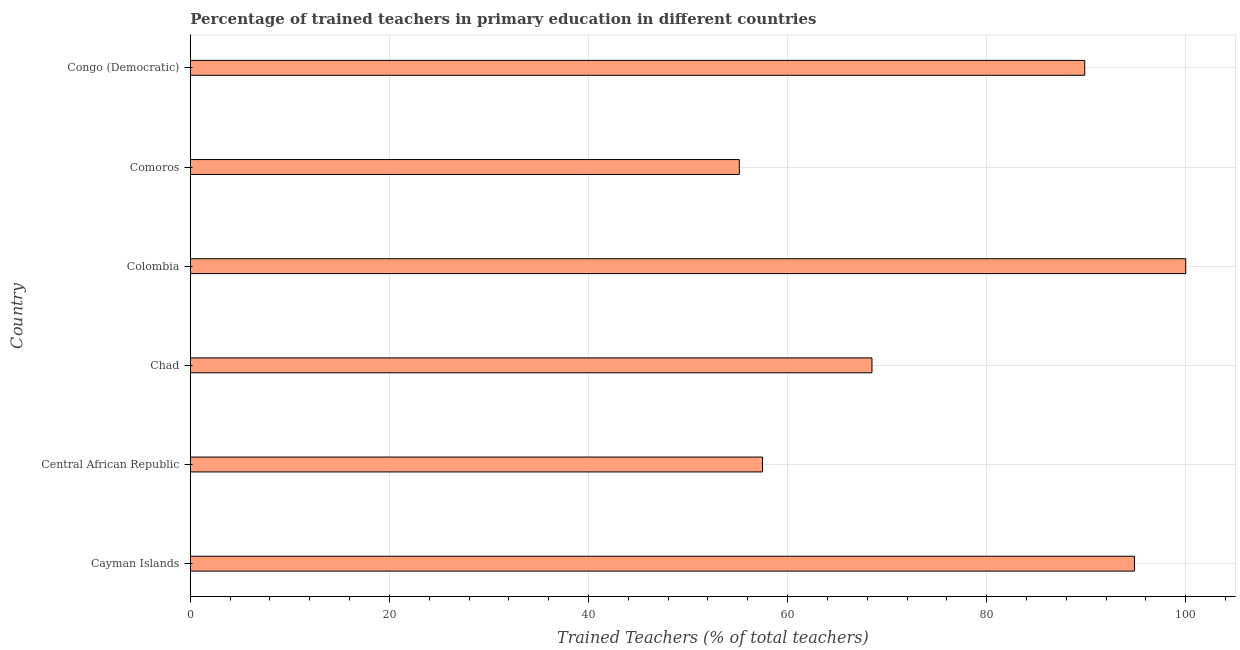Does the graph contain grids?
Give a very brief answer. Yes. What is the title of the graph?
Provide a short and direct response. Percentage of trained teachers in primary education in different countries. What is the label or title of the X-axis?
Your response must be concise. Trained Teachers (% of total teachers). What is the label or title of the Y-axis?
Ensure brevity in your answer.  Country. What is the percentage of trained teachers in Chad?
Make the answer very short. 68.48. Across all countries, what is the minimum percentage of trained teachers?
Your answer should be compact. 55.15. In which country was the percentage of trained teachers maximum?
Provide a succinct answer. Colombia. In which country was the percentage of trained teachers minimum?
Give a very brief answer. Comoros. What is the sum of the percentage of trained teachers?
Your response must be concise. 465.82. What is the difference between the percentage of trained teachers in Colombia and Congo (Democratic)?
Keep it short and to the point. 10.15. What is the average percentage of trained teachers per country?
Give a very brief answer. 77.64. What is the median percentage of trained teachers?
Make the answer very short. 79.17. In how many countries, is the percentage of trained teachers greater than 52 %?
Your response must be concise. 6. What is the ratio of the percentage of trained teachers in Comoros to that in Congo (Democratic)?
Give a very brief answer. 0.61. What is the difference between the highest and the second highest percentage of trained teachers?
Offer a very short reply. 5.15. What is the difference between the highest and the lowest percentage of trained teachers?
Your answer should be compact. 44.85. In how many countries, is the percentage of trained teachers greater than the average percentage of trained teachers taken over all countries?
Provide a succinct answer. 3. Are all the bars in the graph horizontal?
Provide a succinct answer. Yes. How many countries are there in the graph?
Ensure brevity in your answer.  6. What is the Trained Teachers (% of total teachers) of Cayman Islands?
Your response must be concise. 94.85. What is the Trained Teachers (% of total teachers) of Central African Republic?
Keep it short and to the point. 57.49. What is the Trained Teachers (% of total teachers) in Chad?
Keep it short and to the point. 68.48. What is the Trained Teachers (% of total teachers) in Colombia?
Ensure brevity in your answer.  100. What is the Trained Teachers (% of total teachers) of Comoros?
Your answer should be very brief. 55.15. What is the Trained Teachers (% of total teachers) of Congo (Democratic)?
Make the answer very short. 89.85. What is the difference between the Trained Teachers (% of total teachers) in Cayman Islands and Central African Republic?
Your answer should be compact. 37.36. What is the difference between the Trained Teachers (% of total teachers) in Cayman Islands and Chad?
Keep it short and to the point. 26.37. What is the difference between the Trained Teachers (% of total teachers) in Cayman Islands and Colombia?
Ensure brevity in your answer.  -5.15. What is the difference between the Trained Teachers (% of total teachers) in Cayman Islands and Comoros?
Ensure brevity in your answer.  39.69. What is the difference between the Trained Teachers (% of total teachers) in Cayman Islands and Congo (Democratic)?
Offer a terse response. 5. What is the difference between the Trained Teachers (% of total teachers) in Central African Republic and Chad?
Give a very brief answer. -10.99. What is the difference between the Trained Teachers (% of total teachers) in Central African Republic and Colombia?
Make the answer very short. -42.51. What is the difference between the Trained Teachers (% of total teachers) in Central African Republic and Comoros?
Ensure brevity in your answer.  2.33. What is the difference between the Trained Teachers (% of total teachers) in Central African Republic and Congo (Democratic)?
Your answer should be very brief. -32.37. What is the difference between the Trained Teachers (% of total teachers) in Chad and Colombia?
Offer a very short reply. -31.52. What is the difference between the Trained Teachers (% of total teachers) in Chad and Comoros?
Make the answer very short. 13.33. What is the difference between the Trained Teachers (% of total teachers) in Chad and Congo (Democratic)?
Keep it short and to the point. -21.37. What is the difference between the Trained Teachers (% of total teachers) in Colombia and Comoros?
Your answer should be very brief. 44.85. What is the difference between the Trained Teachers (% of total teachers) in Colombia and Congo (Democratic)?
Offer a very short reply. 10.15. What is the difference between the Trained Teachers (% of total teachers) in Comoros and Congo (Democratic)?
Keep it short and to the point. -34.7. What is the ratio of the Trained Teachers (% of total teachers) in Cayman Islands to that in Central African Republic?
Keep it short and to the point. 1.65. What is the ratio of the Trained Teachers (% of total teachers) in Cayman Islands to that in Chad?
Make the answer very short. 1.39. What is the ratio of the Trained Teachers (% of total teachers) in Cayman Islands to that in Colombia?
Ensure brevity in your answer.  0.95. What is the ratio of the Trained Teachers (% of total teachers) in Cayman Islands to that in Comoros?
Provide a succinct answer. 1.72. What is the ratio of the Trained Teachers (% of total teachers) in Cayman Islands to that in Congo (Democratic)?
Provide a short and direct response. 1.06. What is the ratio of the Trained Teachers (% of total teachers) in Central African Republic to that in Chad?
Ensure brevity in your answer.  0.84. What is the ratio of the Trained Teachers (% of total teachers) in Central African Republic to that in Colombia?
Keep it short and to the point. 0.57. What is the ratio of the Trained Teachers (% of total teachers) in Central African Republic to that in Comoros?
Make the answer very short. 1.04. What is the ratio of the Trained Teachers (% of total teachers) in Central African Republic to that in Congo (Democratic)?
Provide a short and direct response. 0.64. What is the ratio of the Trained Teachers (% of total teachers) in Chad to that in Colombia?
Offer a very short reply. 0.69. What is the ratio of the Trained Teachers (% of total teachers) in Chad to that in Comoros?
Your response must be concise. 1.24. What is the ratio of the Trained Teachers (% of total teachers) in Chad to that in Congo (Democratic)?
Provide a succinct answer. 0.76. What is the ratio of the Trained Teachers (% of total teachers) in Colombia to that in Comoros?
Your answer should be very brief. 1.81. What is the ratio of the Trained Teachers (% of total teachers) in Colombia to that in Congo (Democratic)?
Ensure brevity in your answer.  1.11. What is the ratio of the Trained Teachers (% of total teachers) in Comoros to that in Congo (Democratic)?
Your answer should be very brief. 0.61. 